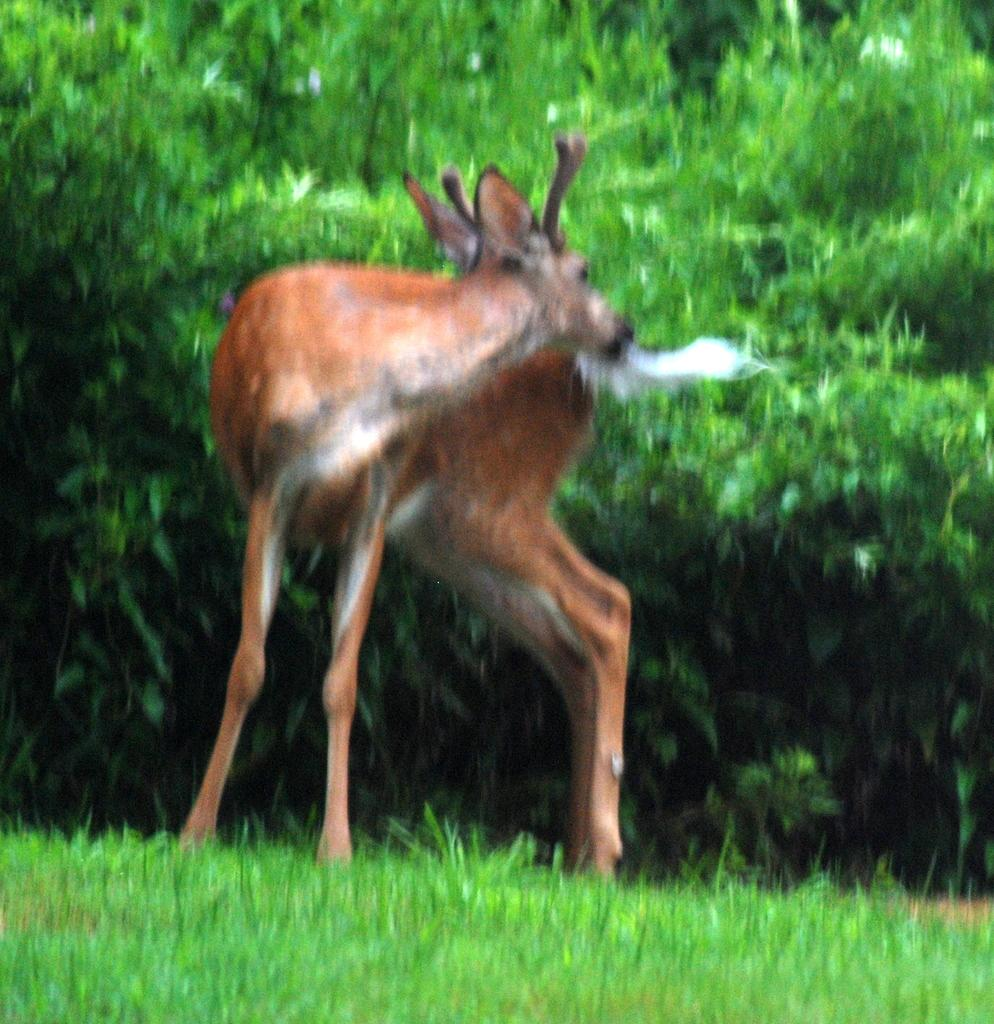What animal can be seen in the image? There is a deer standing in the image. What is the deer doing in the image? The deer is standing in the image. What type of vegetation is present in the image? There is grass in the image. What can be seen in the background of the image? There are trees in the background of the image. What is the color of the trees in the image? The trees are green in color. What type of gold trail can be seen behind the deer in the image? There is no gold trail present in the image; the deer is standing on grass. Is the deer wearing a cap in the image? There is no cap visible on the deer in the image. 